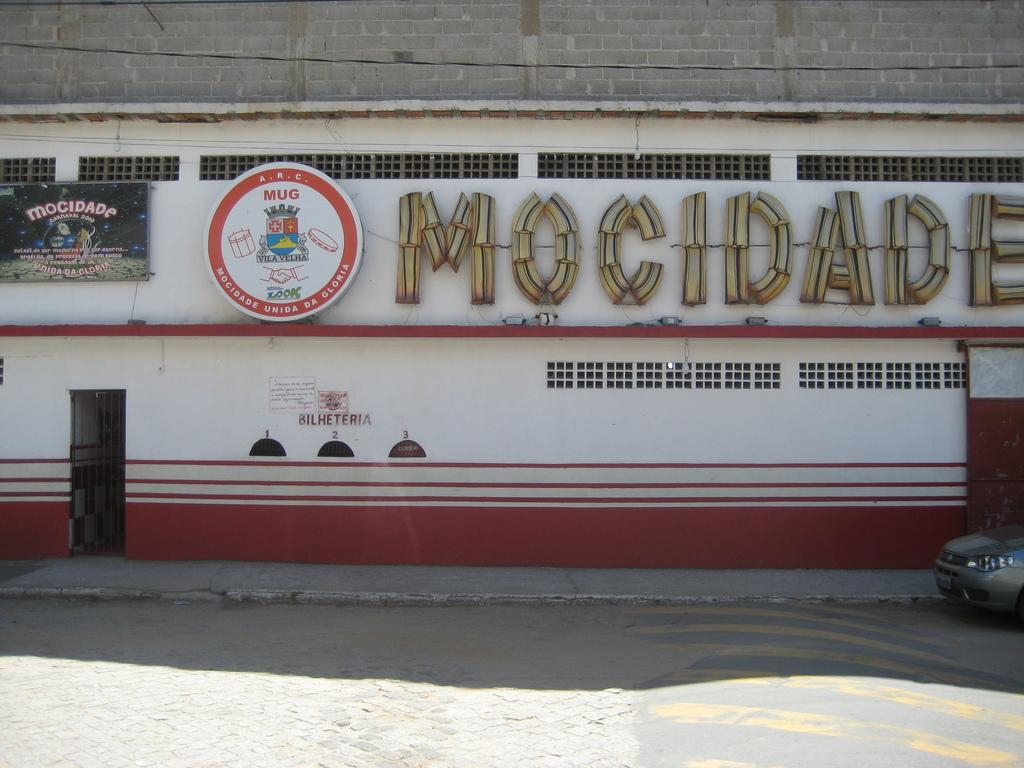What is on the road in the image? There is a vehicle on the road in the image. What is behind the vehicle? There is a wall behind the vehicle. What can be seen on the wall? The wall has a name board, a logo, and a door. Are there any other details visible on the wall? Yes, there are other things visible on the wall. How does the wall give its approval to the vehicle in the image? The wall does not give approval to the vehicle in the image; it is a stationary structure with a name board, logo, and door. 